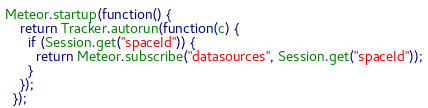<code> <loc_0><loc_0><loc_500><loc_500><_JavaScript_>Meteor.startup(function() {
    return Tracker.autorun(function(c) {
      if (Session.get("spaceId")) {
        return Meteor.subscribe("datasources", Session.get("spaceId"));
      }
    });
  });</code> 